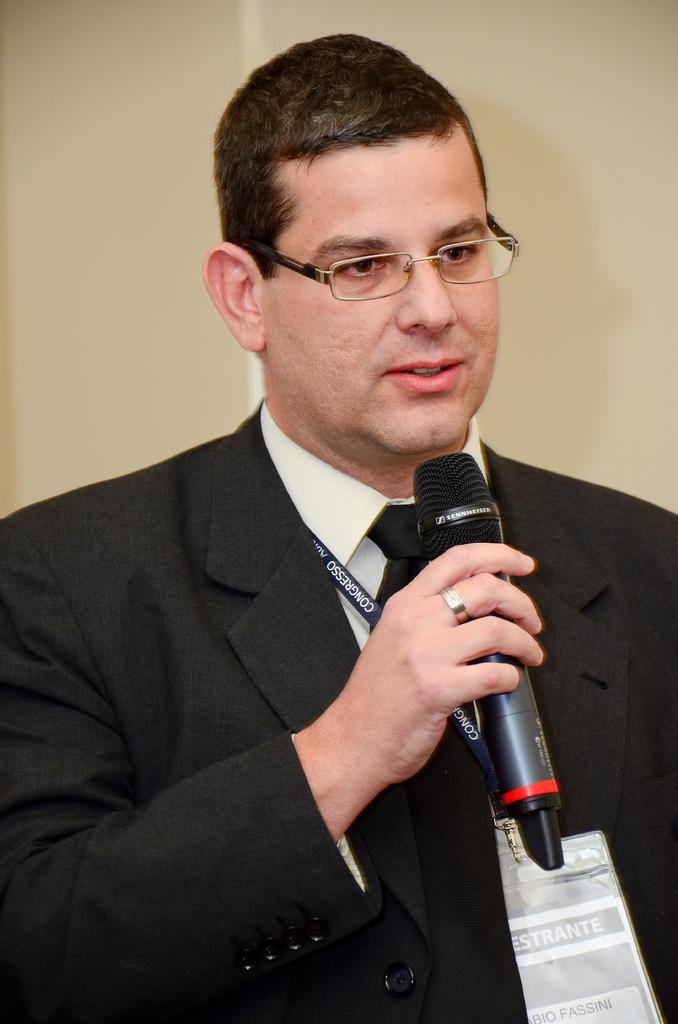What is the man in the image wearing? The man is wearing a black suit, a white shirt, and a tie. What accessory is the man wearing on his face? The man is wearing spectacles. What is the man holding in the image? The man is holding a microphone. What is the man doing in the image? The man is talking. What can be seen in the background of the image? There is a wall in the background of the image. What type of produce is the man holding in the image? There is no produce present in the image; the man is holding a microphone. How many police officers are visible in the image? There are no police officers present in the image; it features a man holding a microphone and talking. 